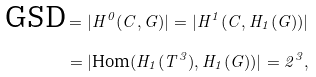Convert formula to latex. <formula><loc_0><loc_0><loc_500><loc_500>\text {GSD} = | H ^ { 0 } ( C , G ) | = | H ^ { 1 } ( C , H _ { 1 } ( G ) ) | \\ = | \text {Hom} ( H _ { 1 } ( T ^ { 3 } ) , H _ { 1 } ( G ) ) | = 2 ^ { 3 } ,</formula> 